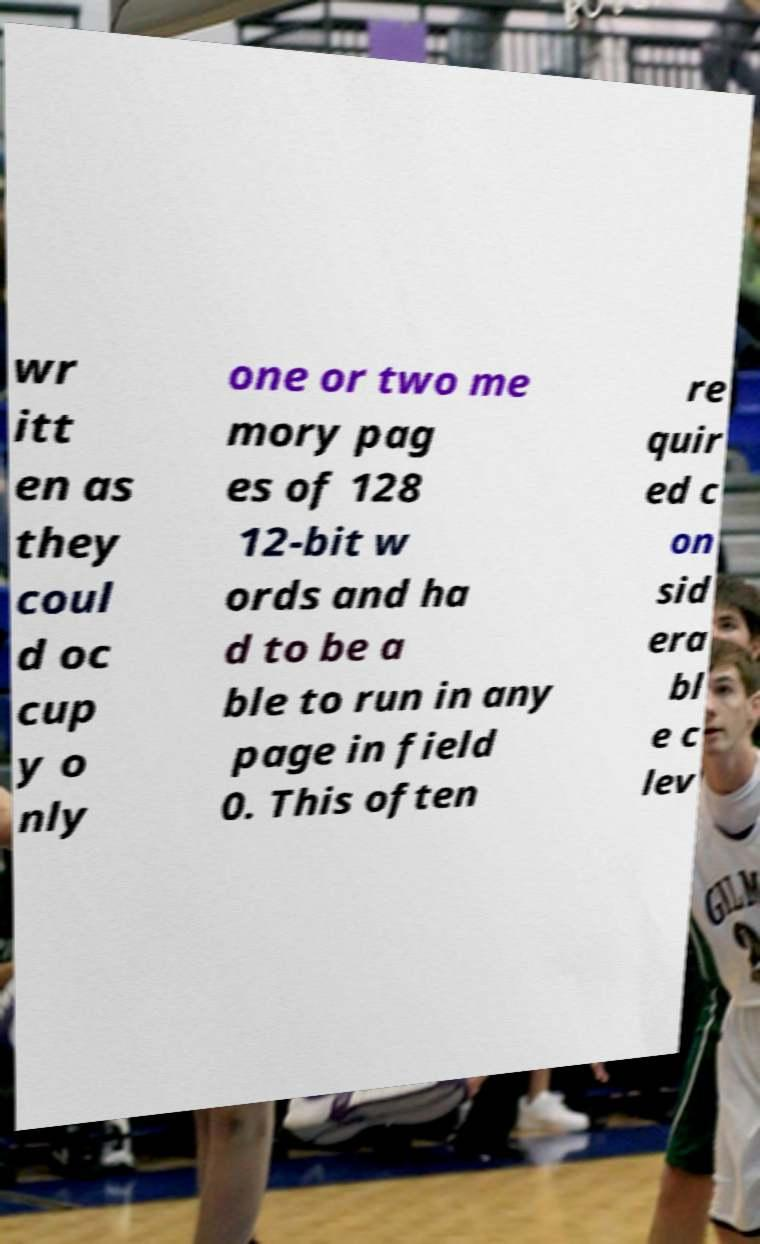There's text embedded in this image that I need extracted. Can you transcribe it verbatim? wr itt en as they coul d oc cup y o nly one or two me mory pag es of 128 12-bit w ords and ha d to be a ble to run in any page in field 0. This often re quir ed c on sid era bl e c lev 